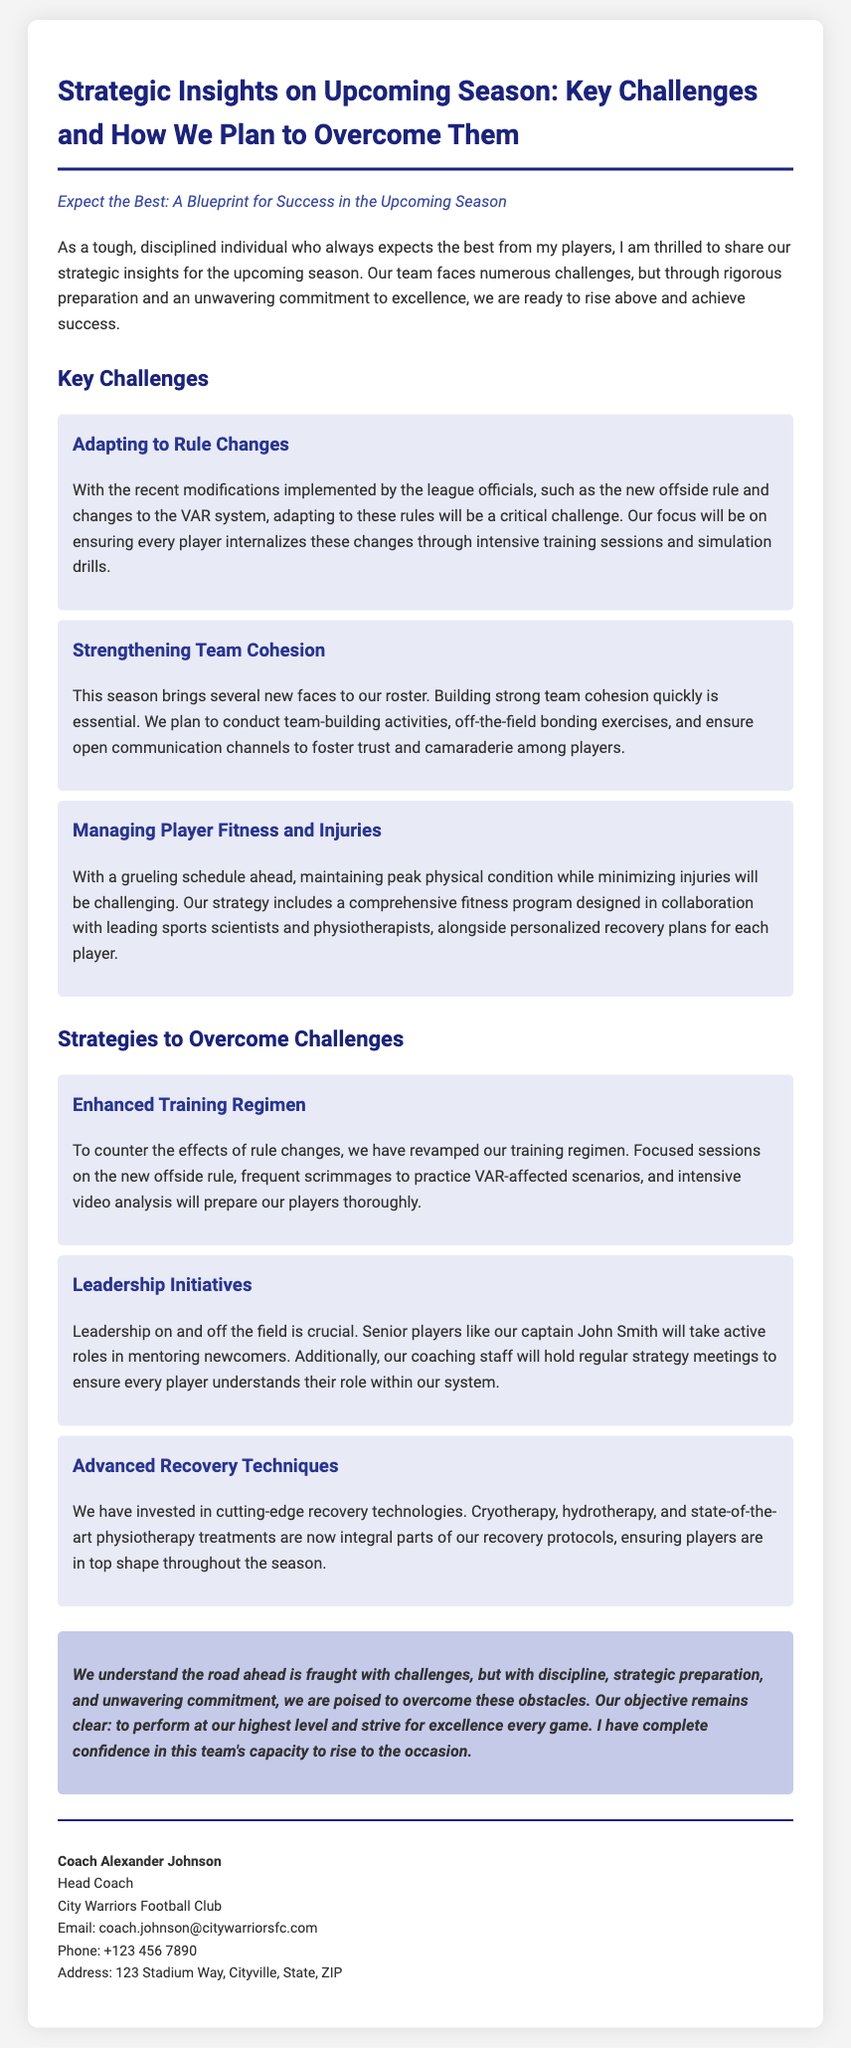What are the key challenges identified for the upcoming season? The document explicitly outlines three key challenges: adapting to rule changes, strengthening team cohesion, and managing player fitness and injuries.
Answer: Adapting to rule changes, strengthening team cohesion, managing player fitness and injuries Who is the head coach mentioned in the press release? The head coach is named at the end of the document, providing direct confirmation.
Answer: Coach Alexander Johnson What is the main focus of the enhanced training regimen? The document specifies that the enhanced training regimen is designed to counter the effects of rule changes through focused sessions and scrimmages.
Answer: Counter the effects of rule changes What technologies have been invested in for player recovery? The document lists specific recovery technologies, indicating a strategic investment for player well-being.
Answer: Cryotherapy, hydrotherapy, physiotherapy How many challenges are highlighted in the press release? By counting the challenges listed in the document, one can quickly determine the total number highlighted.
Answer: Three What role will senior players play according to the strategies presented? The document emphasizes the importance of senior players in mentoring newcomers, highlighting the leadership dynamics in the team.
Answer: Mentoring newcomers What is the purpose of team-building activities mentioned in the document? The purpose is clearly stated as a means to quickly establish strong team cohesion among players.
Answer: Establish strong team cohesion Which system changes mentioned will require adaptation from players? The specific changes outlined that require adaptation from players include the new offside rule and changes to the VAR system.
Answer: New offside rule, VAR system changes 